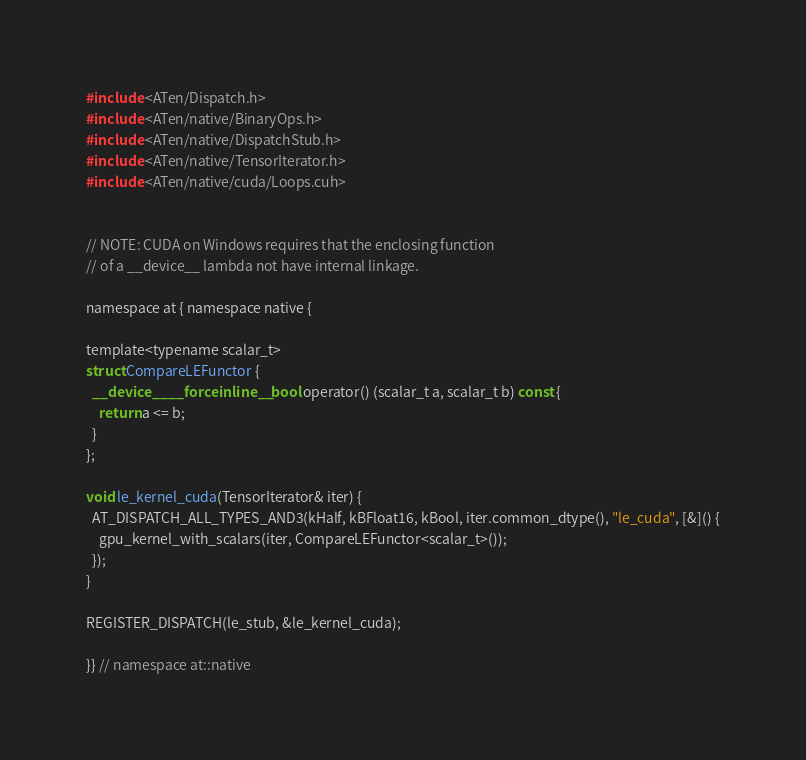Convert code to text. <code><loc_0><loc_0><loc_500><loc_500><_Cuda_>#include <ATen/Dispatch.h>
#include <ATen/native/BinaryOps.h>
#include <ATen/native/DispatchStub.h>
#include <ATen/native/TensorIterator.h>
#include <ATen/native/cuda/Loops.cuh>


// NOTE: CUDA on Windows requires that the enclosing function
// of a __device__ lambda not have internal linkage.

namespace at { namespace native {

template<typename scalar_t>
struct CompareLEFunctor {
  __device__ __forceinline__ bool operator() (scalar_t a, scalar_t b) const {
    return a <= b;
  }
};

void le_kernel_cuda(TensorIterator& iter) {
  AT_DISPATCH_ALL_TYPES_AND3(kHalf, kBFloat16, kBool, iter.common_dtype(), "le_cuda", [&]() {
    gpu_kernel_with_scalars(iter, CompareLEFunctor<scalar_t>());
  });
}

REGISTER_DISPATCH(le_stub, &le_kernel_cuda);

}} // namespace at::native
</code> 